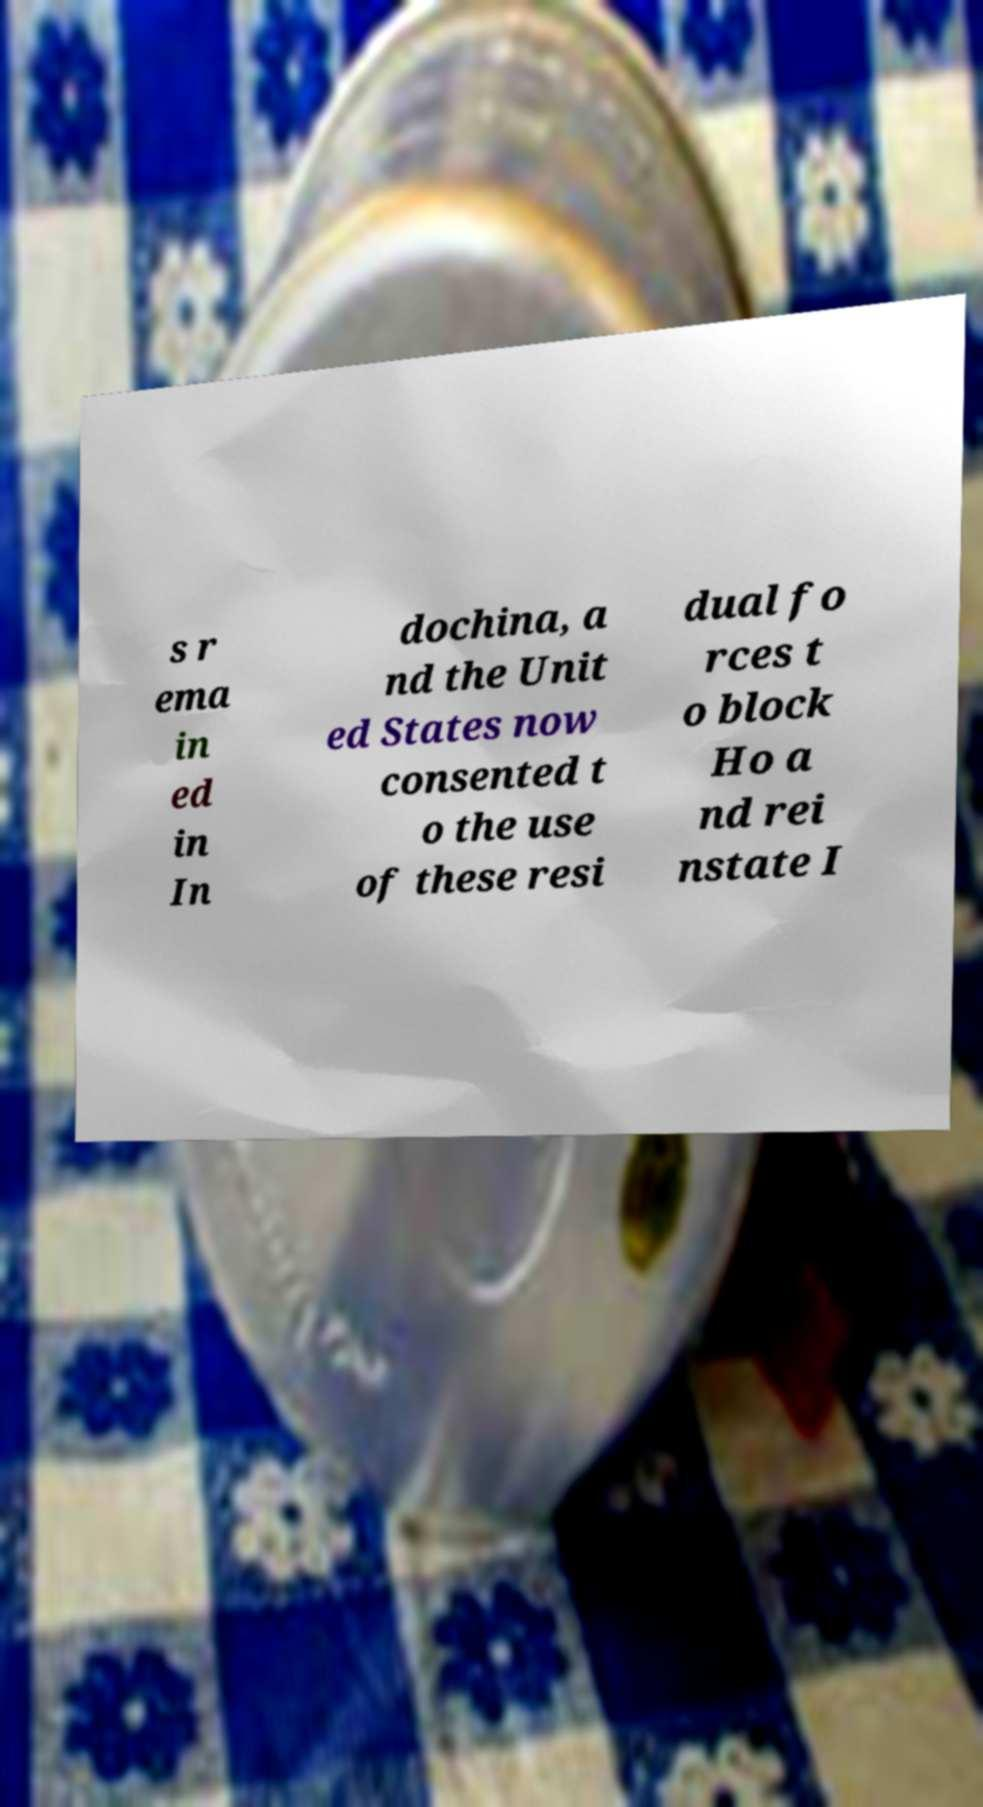Please read and relay the text visible in this image. What does it say? s r ema in ed in In dochina, a nd the Unit ed States now consented t o the use of these resi dual fo rces t o block Ho a nd rei nstate I 